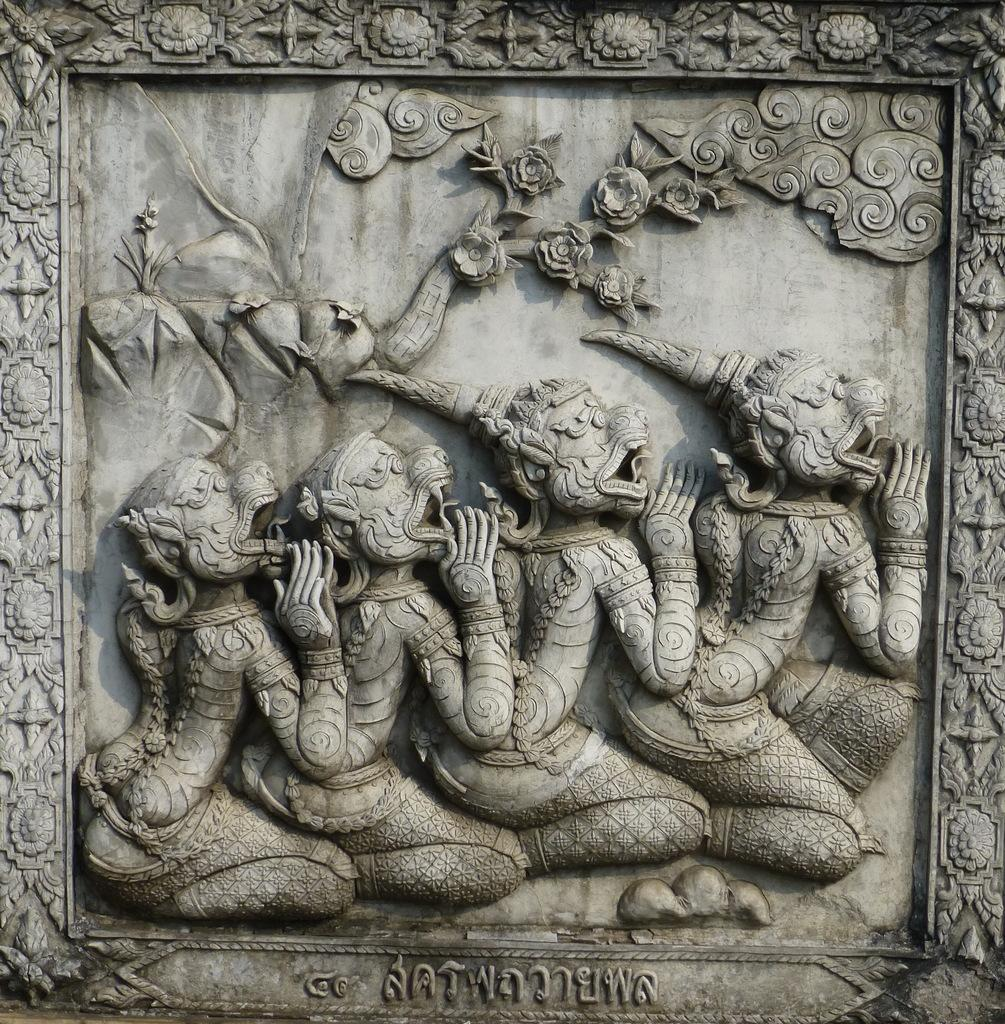What is the main subject of the image? The main subject of the image is a sculpture. Is there any text associated with the image? Yes, there is text at the bottom of the image. What type of bridge can be seen in the image? There is no bridge present in the image; it features a sculpture and text. What material is the marble pipe made of in the image? There is no marble pipe present in the image. 